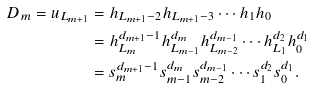Convert formula to latex. <formula><loc_0><loc_0><loc_500><loc_500>D _ { m } = u _ { L _ { m + 1 } } & = h _ { L _ { m + 1 } - 2 } h _ { L _ { m + 1 } - 3 } \cdots h _ { 1 } h _ { 0 } \\ & = h _ { L _ { m } } ^ { d _ { m + 1 } - 1 } h _ { L _ { m - 1 } } ^ { d _ { m } } h _ { L _ { m - 2 } } ^ { d _ { m - 1 } } \cdots h _ { L _ { 1 } } ^ { d _ { 2 } } h _ { 0 } ^ { d _ { 1 } } \\ & = s _ { m } ^ { d _ { m + 1 } - 1 } s _ { m - 1 } ^ { d _ { m } } s _ { m - 2 } ^ { d _ { m - 1 } } \cdots s _ { 1 } ^ { d _ { 2 } } s _ { 0 } ^ { d _ { 1 } } .</formula> 